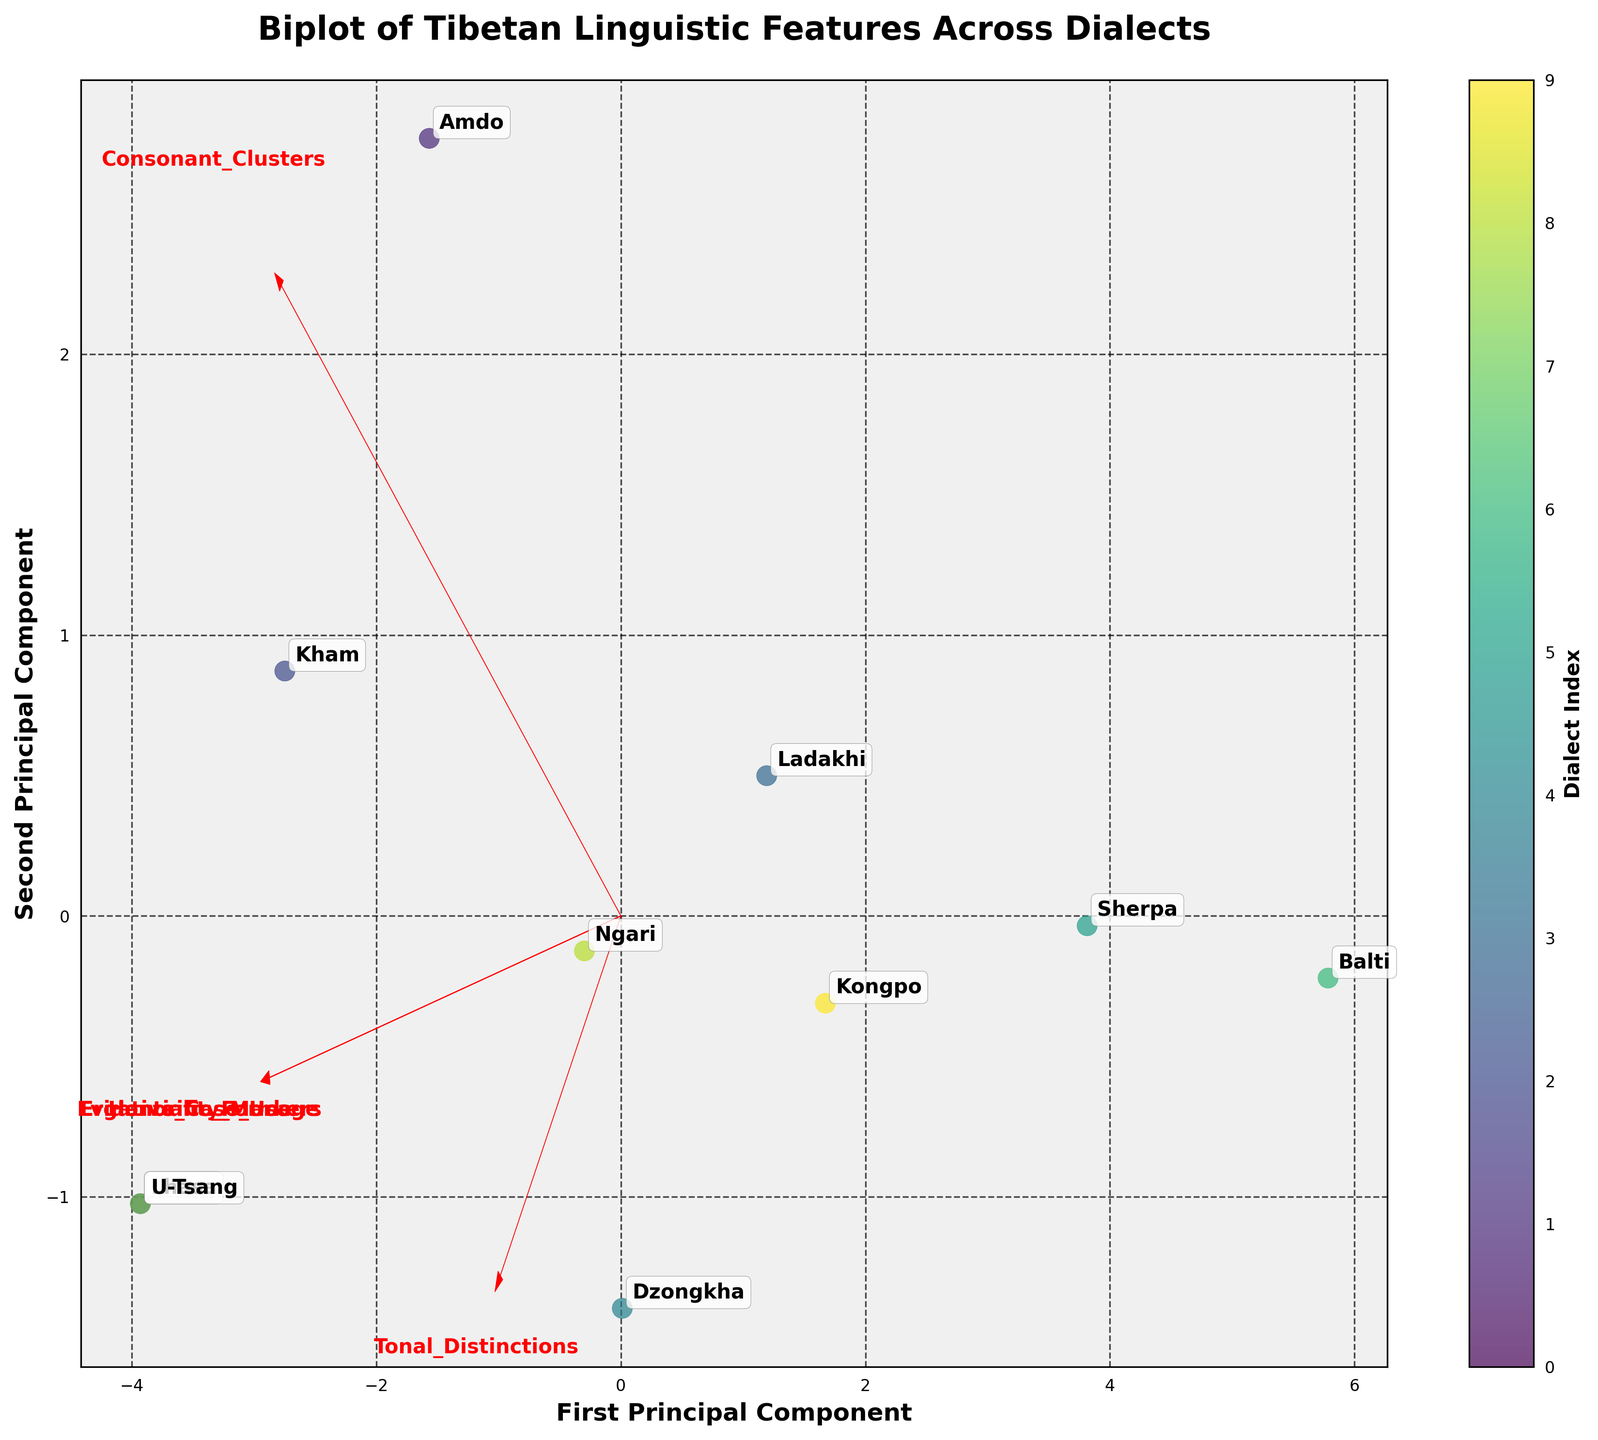What is the title of the biplot? The title of the biplot is displayed at the top of the figure, usually in larger and bold font to make it distinct and easily readable.
Answer: Biplot of Tibetan Linguistic Features Across Dialects How many principal components are displayed in the plot? The plot displays two axes labeled "First Principal Component" and "Second Principal Component," indicating the two principal components visualized.
Answer: Two Which dialects are most similar based on their placement in the biplot? Dialects placed close to each other in the biplot indicate that they have similar linguistic features. Specifically, look for pairs of points that are proximal to determine similarity.
Answer: Lhasa and U-Tsang Which features have the highest influence on the first principal component? Feature vectors pointing along the first principal component axis indicate the features with high influence. The longer the vector and the closer it aligns with the axis, the higher the influence.
Answer: Consonant Clusters and Honorific Forms How does Ladakhi compare to Sherpa in terms of placement on the principal components? To compare Ladakhi and Sherpa, locate their points in the biplot and observe their positions along the first and second principal components to see any notable differences or similarities.
Answer: Ladakhi is located higher on the second principal component than Sherpa Which feature is represented by the vector pointing almost horizontally? Vectors pointing horizontally (along the first principal component axis) indicate the feature they represent. Look for the label near this vector.
Answer: Honorific Forms Are Consonant Clusters positively or negatively correlated with Ergative Case Usage? To determine the correlation, examine the direction of the vectors for Consonant Clusters and Ergative Case Usage. If they point in the same direction, they are positively correlated; if opposite, negatively correlated.
Answer: Positively correlated Which dialect has the highest value for Evidentiality Markers? Compare the positions of the dialect points along the vector representing Evidentiality Markers. The further a point projects in the direction of the vector, the higher its value for that feature.
Answer: Lhasa What can you infer about Amdo dialect's relationship to the features compared to Balti dialect? Analyze the placement of Amdo and Balti dialetcs concerning the feature vectors. Identify if Amdo projects significantly differently on key feature vectors compared to Balti, indicating distinct linguistic features.
Answer: Amdo has higher Consonant Clusters and slightly higher Honorific Forms than Balti Among Lhasa, Amdo, and Kham, which one has the most balanced feature profile according to the biplot? A balanced feature profile in the biplot would imply a dialect positioned centrally near the origin, not extreme on any principal components, indicating moderate values across features.
Answer: Kham 